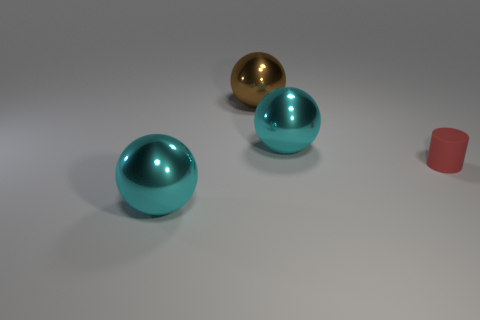Add 3 large objects. How many objects exist? 7 Subtract all balls. How many objects are left? 1 Subtract all brown objects. Subtract all spheres. How many objects are left? 0 Add 1 tiny cylinders. How many tiny cylinders are left? 2 Add 4 brown shiny blocks. How many brown shiny blocks exist? 4 Subtract 0 gray blocks. How many objects are left? 4 